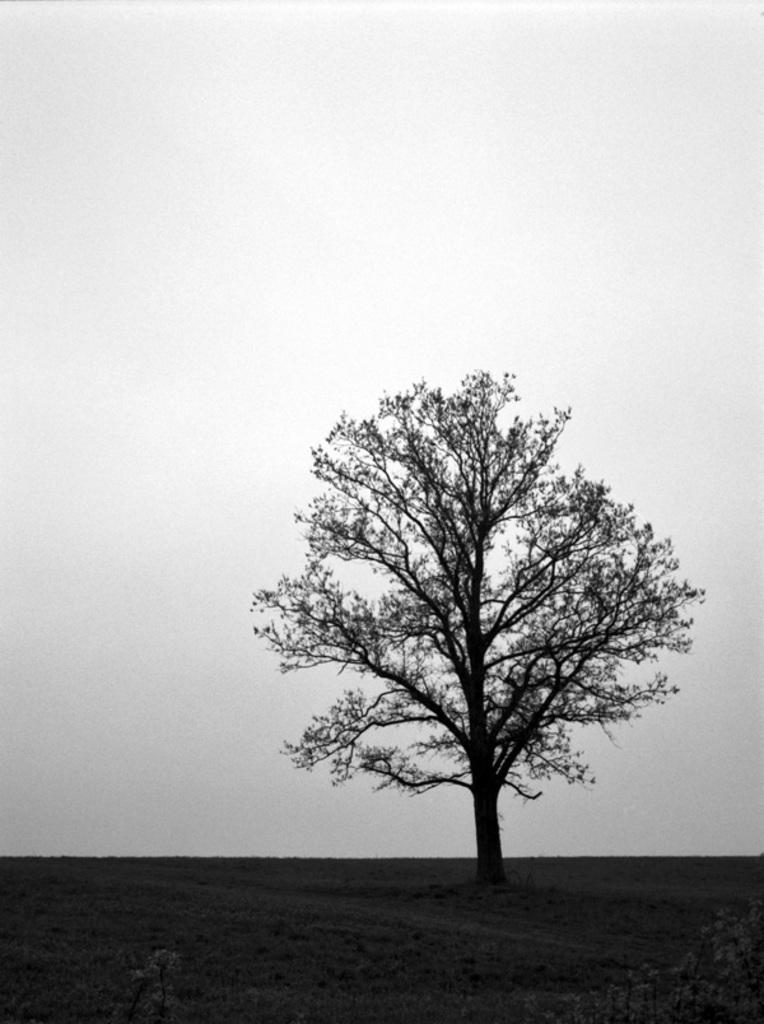What type of natural feature can be seen in the image? There is a tree visible in the image. Where is the tree located? The tree is on land. What can be seen behind the tree? The sky is visible behind the tree. Are there any celestial bodies visible in the image? There may be small planets visible at the bottom of the image. What type of advice can be seen being given by the tree in the image? There is no advice being given by the tree in the image, as trees do not have the ability to provide advice. 